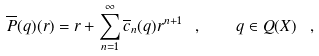<formula> <loc_0><loc_0><loc_500><loc_500>\overline { P } ( q ) ( r ) = r + \sum _ { n = 1 } ^ { \infty } \overline { c } _ { n } ( q ) r ^ { n + 1 } \ , \quad q \in Q ( X ) \ ,</formula> 